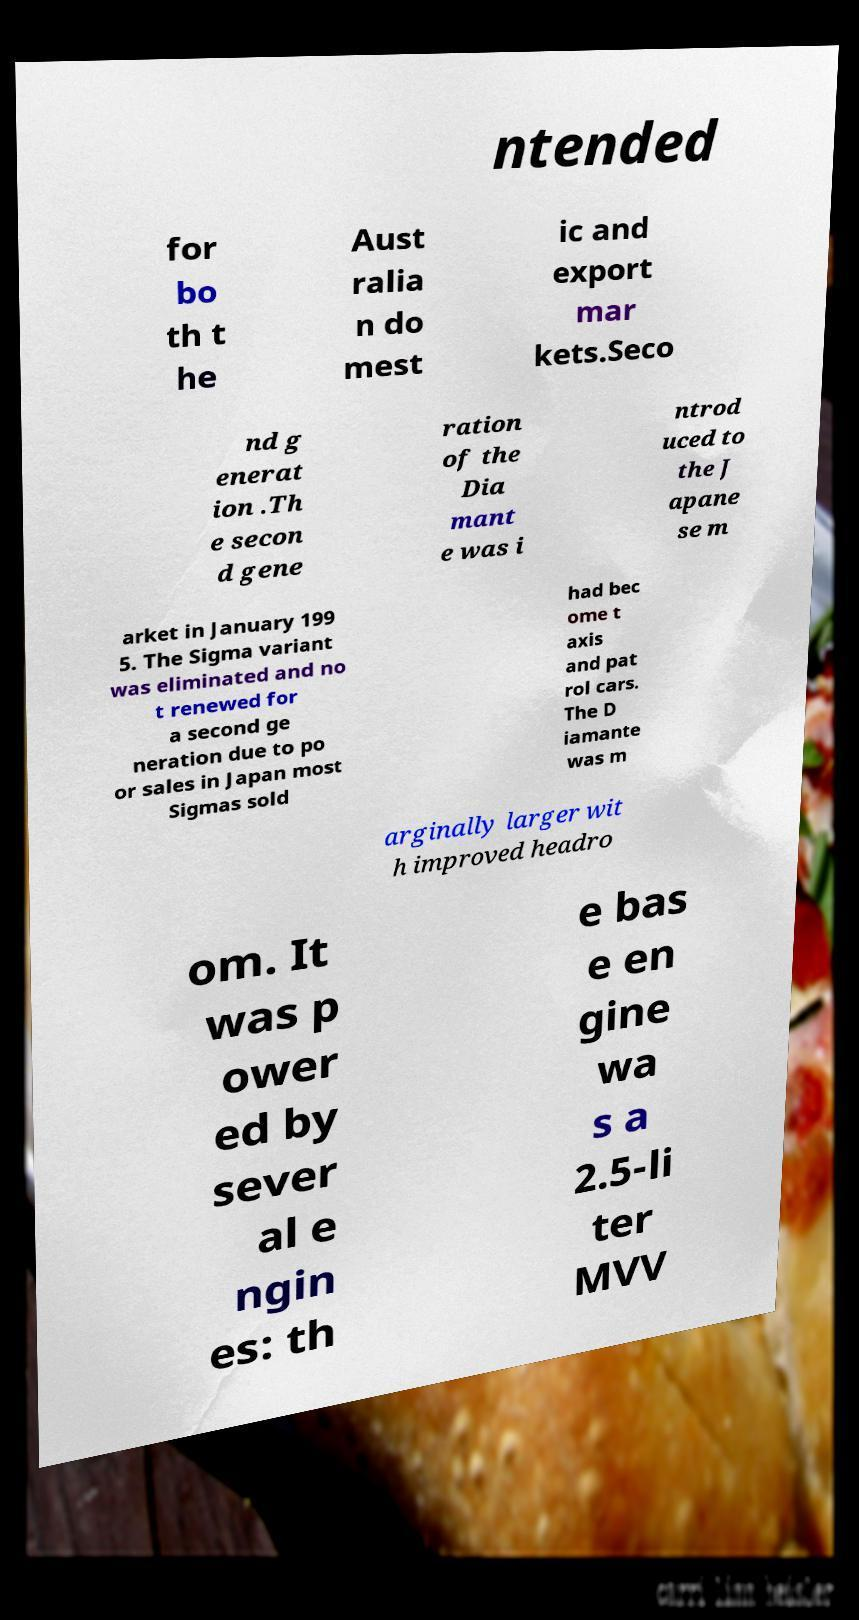Can you accurately transcribe the text from the provided image for me? ntended for bo th t he Aust ralia n do mest ic and export mar kets.Seco nd g enerat ion .Th e secon d gene ration of the Dia mant e was i ntrod uced to the J apane se m arket in January 199 5. The Sigma variant was eliminated and no t renewed for a second ge neration due to po or sales in Japan most Sigmas sold had bec ome t axis and pat rol cars. The D iamante was m arginally larger wit h improved headro om. It was p ower ed by sever al e ngin es: th e bas e en gine wa s a 2.5-li ter MVV 